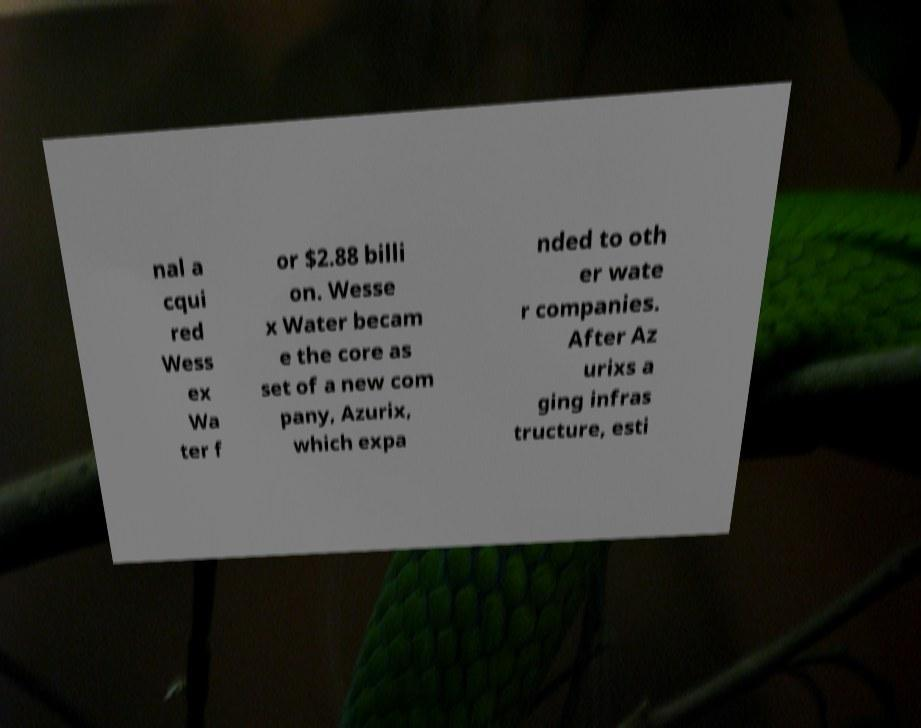Can you accurately transcribe the text from the provided image for me? nal a cqui red Wess ex Wa ter f or $2.88 billi on. Wesse x Water becam e the core as set of a new com pany, Azurix, which expa nded to oth er wate r companies. After Az urixs a ging infras tructure, esti 